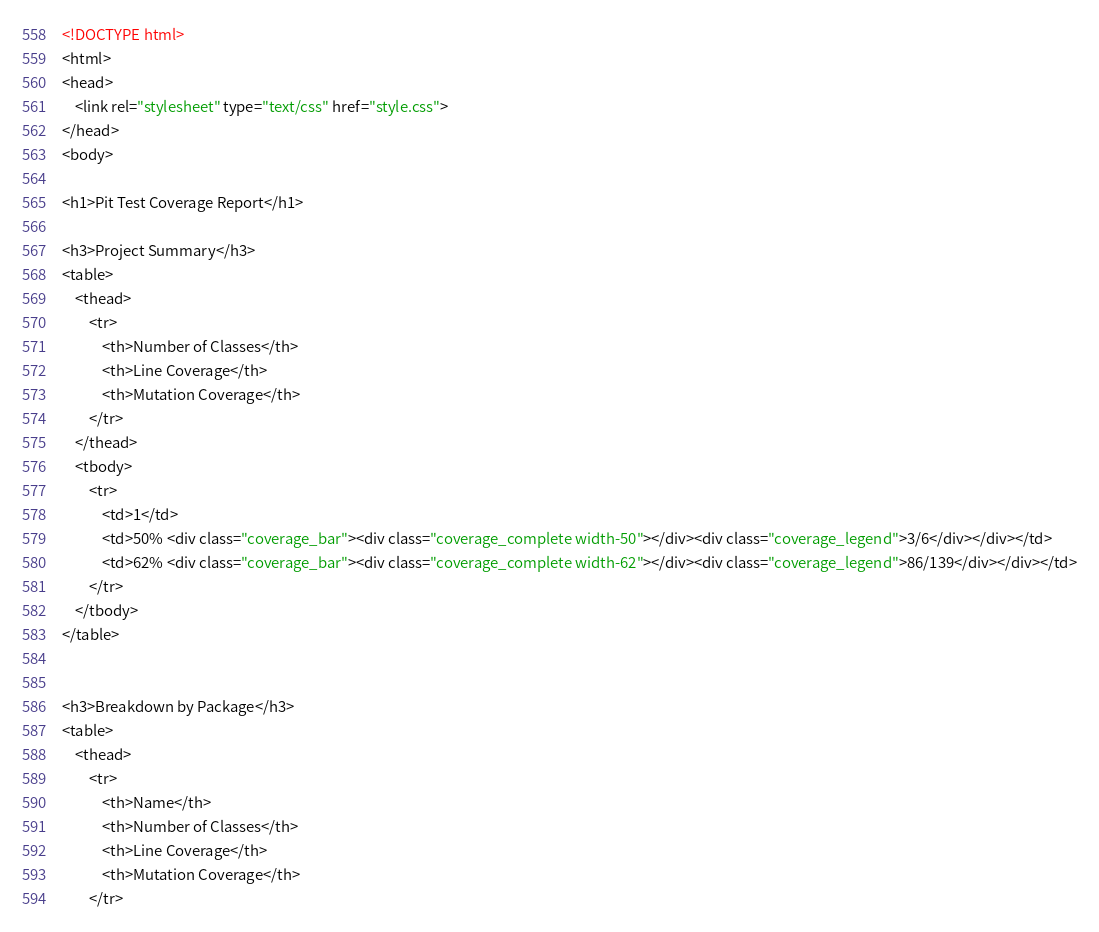<code> <loc_0><loc_0><loc_500><loc_500><_HTML_><!DOCTYPE html>
<html>
<head>
    <link rel="stylesheet" type="text/css" href="style.css">
</head>
<body>

<h1>Pit Test Coverage Report</h1>

<h3>Project Summary</h3>
<table>
    <thead>
        <tr>
            <th>Number of Classes</th>
            <th>Line Coverage</th>
            <th>Mutation Coverage</th>
        </tr>
    </thead>
    <tbody>
        <tr>
            <td>1</td>
            <td>50% <div class="coverage_bar"><div class="coverage_complete width-50"></div><div class="coverage_legend">3/6</div></div></td>
            <td>62% <div class="coverage_bar"><div class="coverage_complete width-62"></div><div class="coverage_legend">86/139</div></div></td>
        </tr>
    </tbody>
</table>


<h3>Breakdown by Package</h3>
<table>
    <thead>
        <tr>
            <th>Name</th>
            <th>Number of Classes</th>
            <th>Line Coverage</th>
            <th>Mutation Coverage</th>
        </tr></code> 